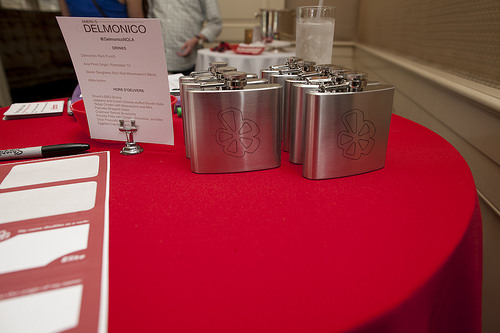<image>
Is the lid on the bottle? No. The lid is not positioned on the bottle. They may be near each other, but the lid is not supported by or resting on top of the bottle. 